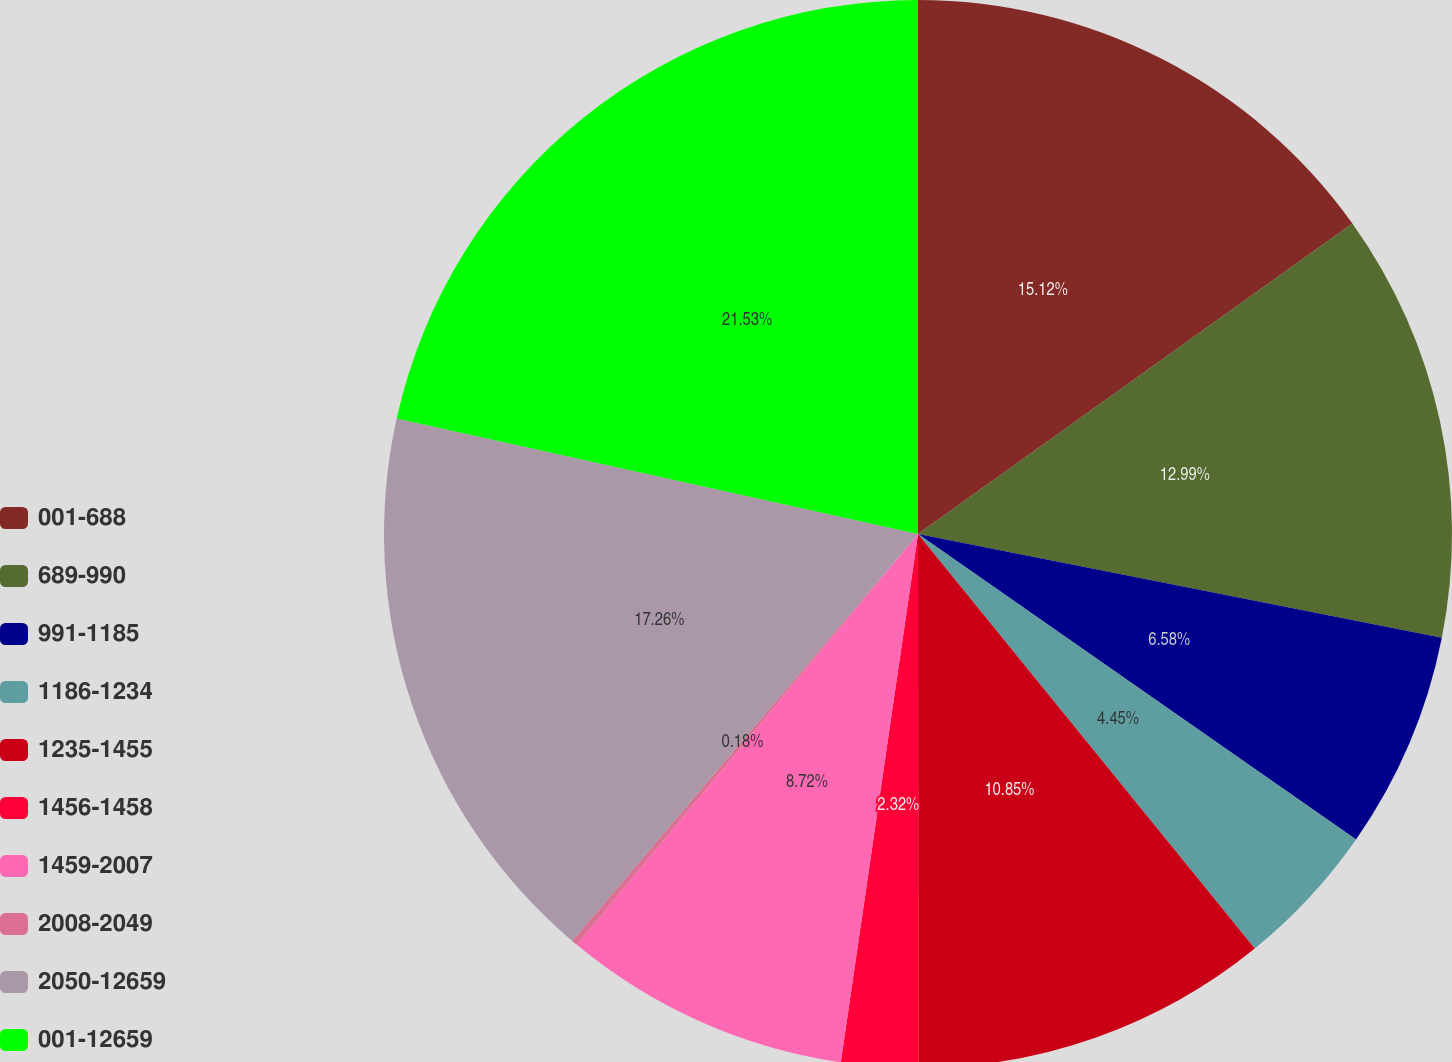Convert chart. <chart><loc_0><loc_0><loc_500><loc_500><pie_chart><fcel>001-688<fcel>689-990<fcel>991-1185<fcel>1186-1234<fcel>1235-1455<fcel>1456-1458<fcel>1459-2007<fcel>2008-2049<fcel>2050-12659<fcel>001-12659<nl><fcel>15.12%<fcel>12.99%<fcel>6.58%<fcel>4.45%<fcel>10.85%<fcel>2.32%<fcel>8.72%<fcel>0.18%<fcel>17.26%<fcel>21.53%<nl></chart> 